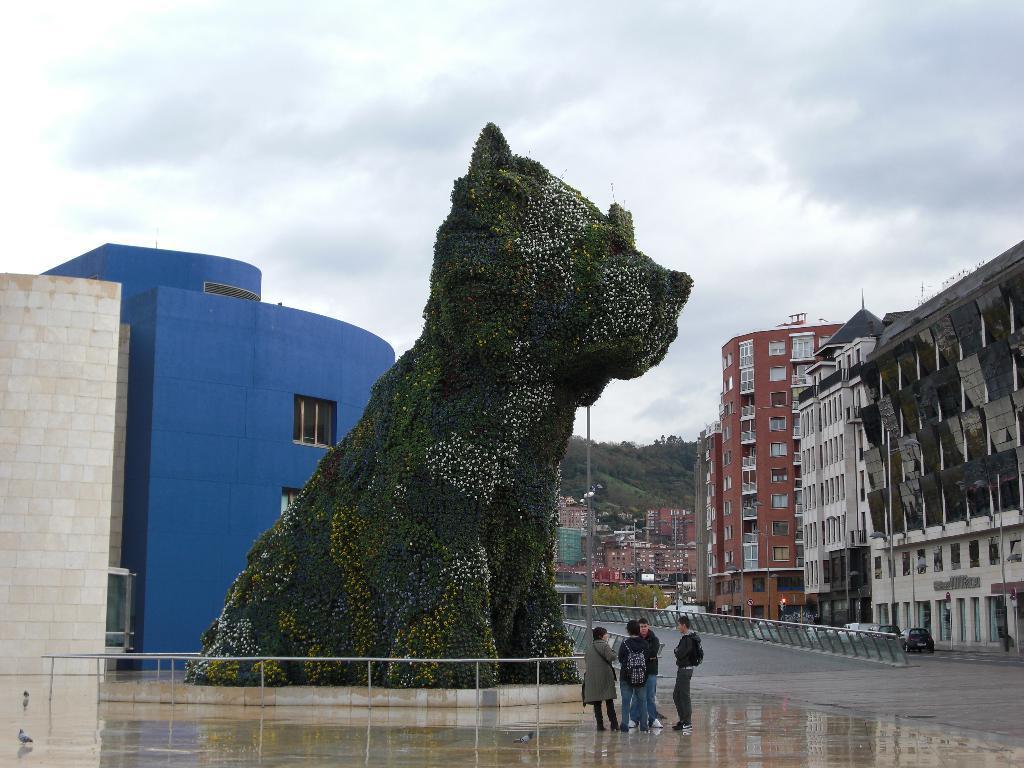How would you summarize this image in a sentence or two? In this picture we can see four people carrying bags, standing on the ground, vehicles on the road, statue, poles, trees, birds, buildings with windows, some objects and in the background we can see the sky with clouds. 